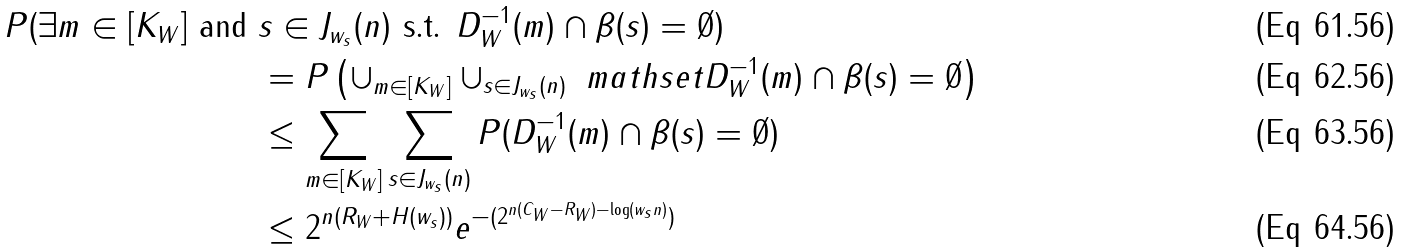Convert formula to latex. <formula><loc_0><loc_0><loc_500><loc_500>P ( \exists m \in [ K _ { W } ] \text { and } & s \in J _ { w _ { s } } ( n ) \text { s.t. } D _ { W } ^ { - 1 } ( m ) \cap \beta ( s ) = \emptyset ) \\ & = P \left ( \cup _ { m \in [ K _ { W } ] } \cup _ { s \in J _ { w _ { s } } ( n ) } \ m a t h s e t { D _ { W } ^ { - 1 } ( m ) \cap \beta ( s ) = \emptyset } \right ) \\ & \leq \sum _ { m \in [ K _ { W } ] } \sum _ { s \in J _ { w _ { s } } ( n ) } P ( D _ { W } ^ { - 1 } ( m ) \cap \beta ( s ) = \emptyset ) \\ & \leq 2 ^ { n ( R _ { W } + H ( w _ { s } ) ) } e ^ { - ( 2 ^ { n ( C _ { W } - R _ { W } ) - \log ( w _ { s } n ) } ) }</formula> 